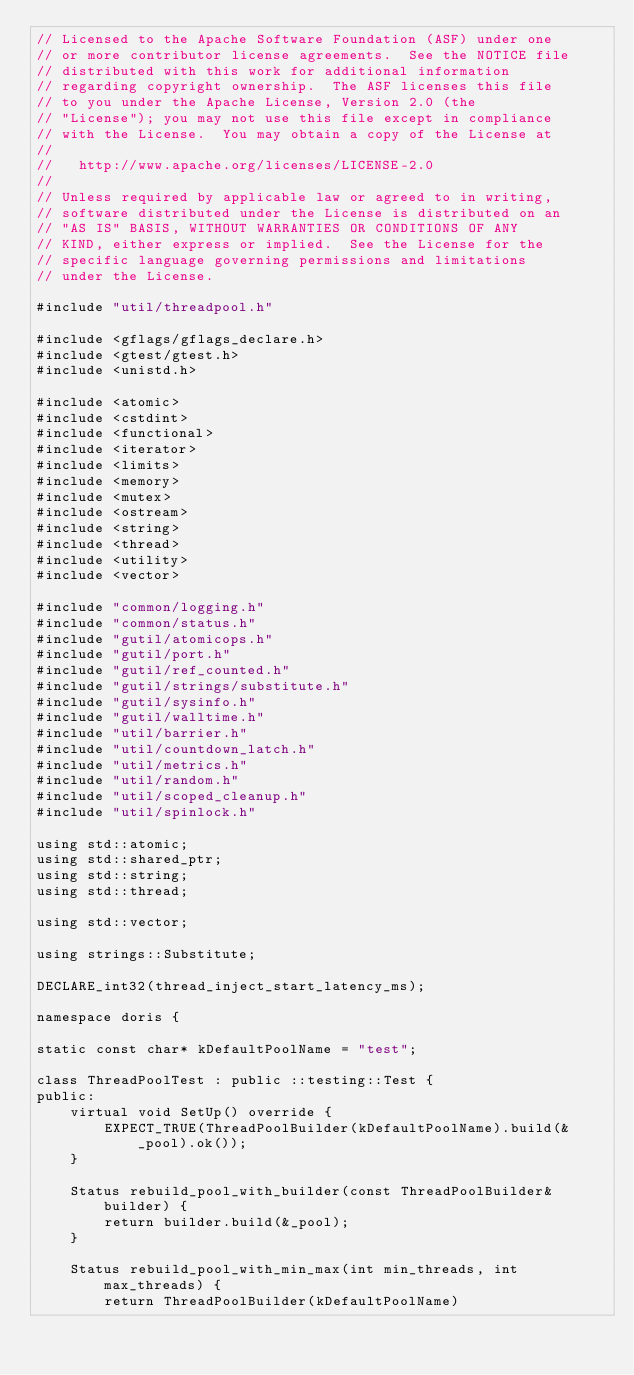<code> <loc_0><loc_0><loc_500><loc_500><_C++_>// Licensed to the Apache Software Foundation (ASF) under one
// or more contributor license agreements.  See the NOTICE file
// distributed with this work for additional information
// regarding copyright ownership.  The ASF licenses this file
// to you under the Apache License, Version 2.0 (the
// "License"); you may not use this file except in compliance
// with the License.  You may obtain a copy of the License at
//
//   http://www.apache.org/licenses/LICENSE-2.0
//
// Unless required by applicable law or agreed to in writing,
// software distributed under the License is distributed on an
// "AS IS" BASIS, WITHOUT WARRANTIES OR CONDITIONS OF ANY
// KIND, either express or implied.  See the License for the
// specific language governing permissions and limitations
// under the License.

#include "util/threadpool.h"

#include <gflags/gflags_declare.h>
#include <gtest/gtest.h>
#include <unistd.h>

#include <atomic>
#include <cstdint>
#include <functional>
#include <iterator>
#include <limits>
#include <memory>
#include <mutex>
#include <ostream>
#include <string>
#include <thread>
#include <utility>
#include <vector>

#include "common/logging.h"
#include "common/status.h"
#include "gutil/atomicops.h"
#include "gutil/port.h"
#include "gutil/ref_counted.h"
#include "gutil/strings/substitute.h"
#include "gutil/sysinfo.h"
#include "gutil/walltime.h"
#include "util/barrier.h"
#include "util/countdown_latch.h"
#include "util/metrics.h"
#include "util/random.h"
#include "util/scoped_cleanup.h"
#include "util/spinlock.h"

using std::atomic;
using std::shared_ptr;
using std::string;
using std::thread;

using std::vector;

using strings::Substitute;

DECLARE_int32(thread_inject_start_latency_ms);

namespace doris {

static const char* kDefaultPoolName = "test";

class ThreadPoolTest : public ::testing::Test {
public:
    virtual void SetUp() override {
        EXPECT_TRUE(ThreadPoolBuilder(kDefaultPoolName).build(&_pool).ok());
    }

    Status rebuild_pool_with_builder(const ThreadPoolBuilder& builder) {
        return builder.build(&_pool);
    }

    Status rebuild_pool_with_min_max(int min_threads, int max_threads) {
        return ThreadPoolBuilder(kDefaultPoolName)</code> 